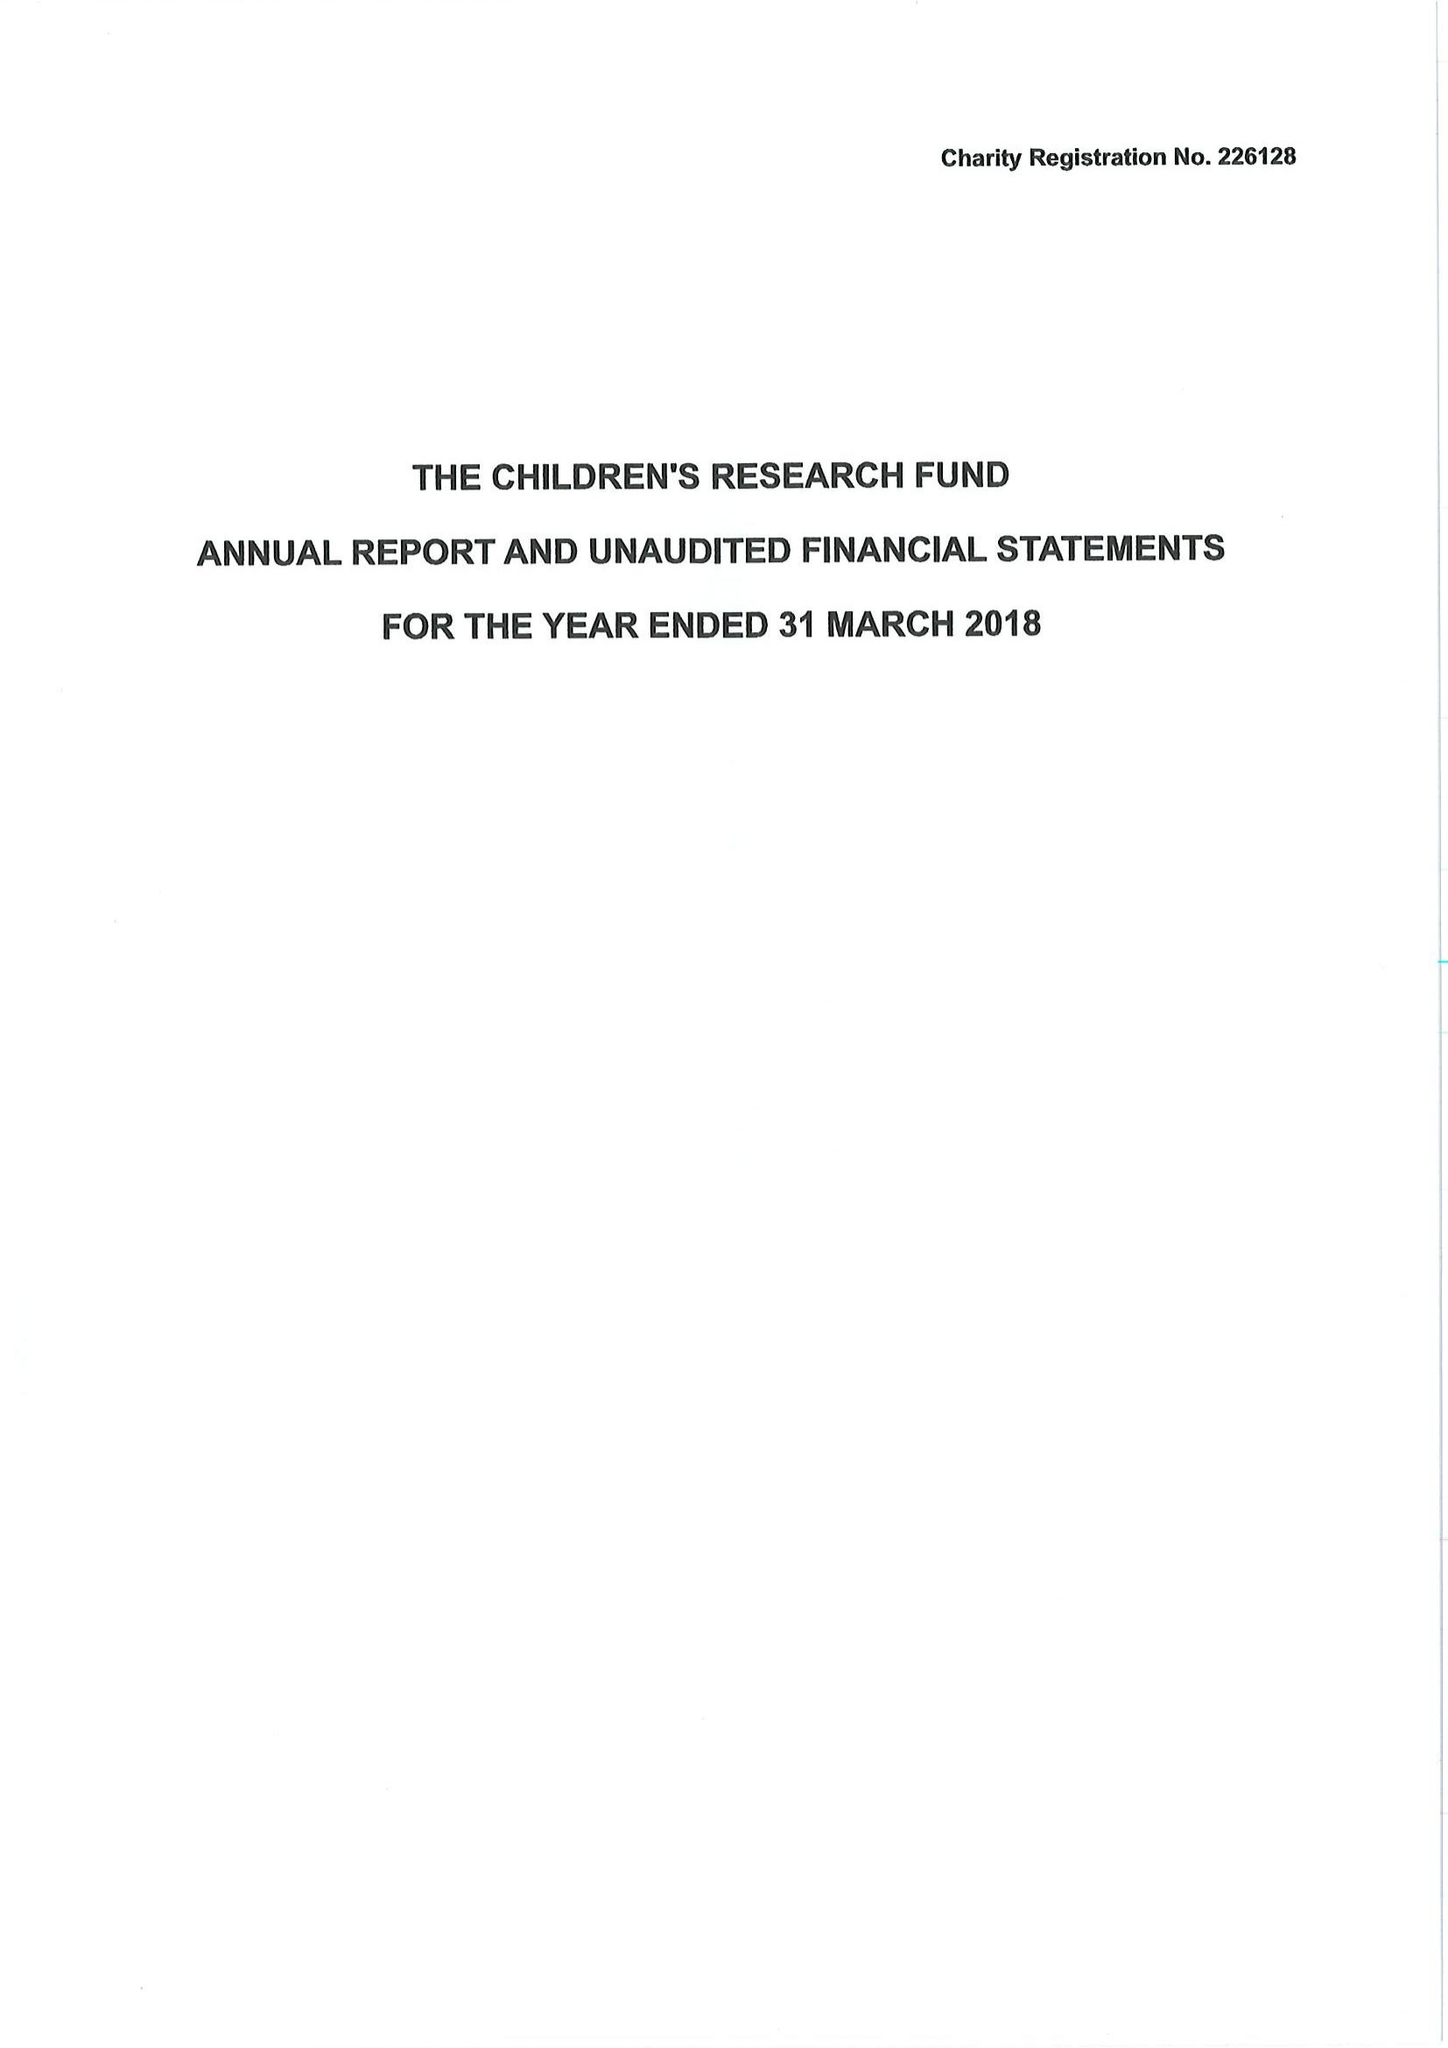What is the value for the charity_number?
Answer the question using a single word or phrase. 226128 